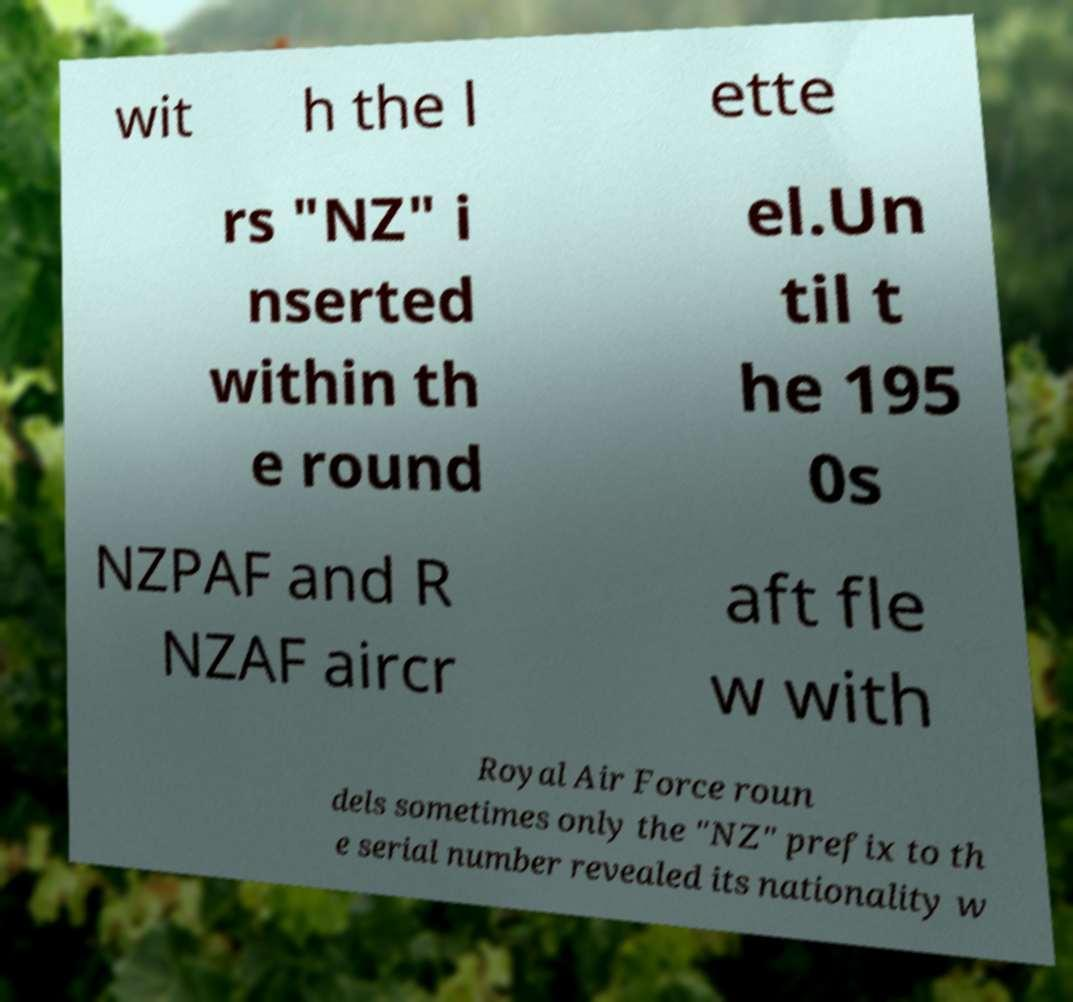Please read and relay the text visible in this image. What does it say? wit h the l ette rs "NZ" i nserted within th e round el.Un til t he 195 0s NZPAF and R NZAF aircr aft fle w with Royal Air Force roun dels sometimes only the "NZ" prefix to th e serial number revealed its nationality w 